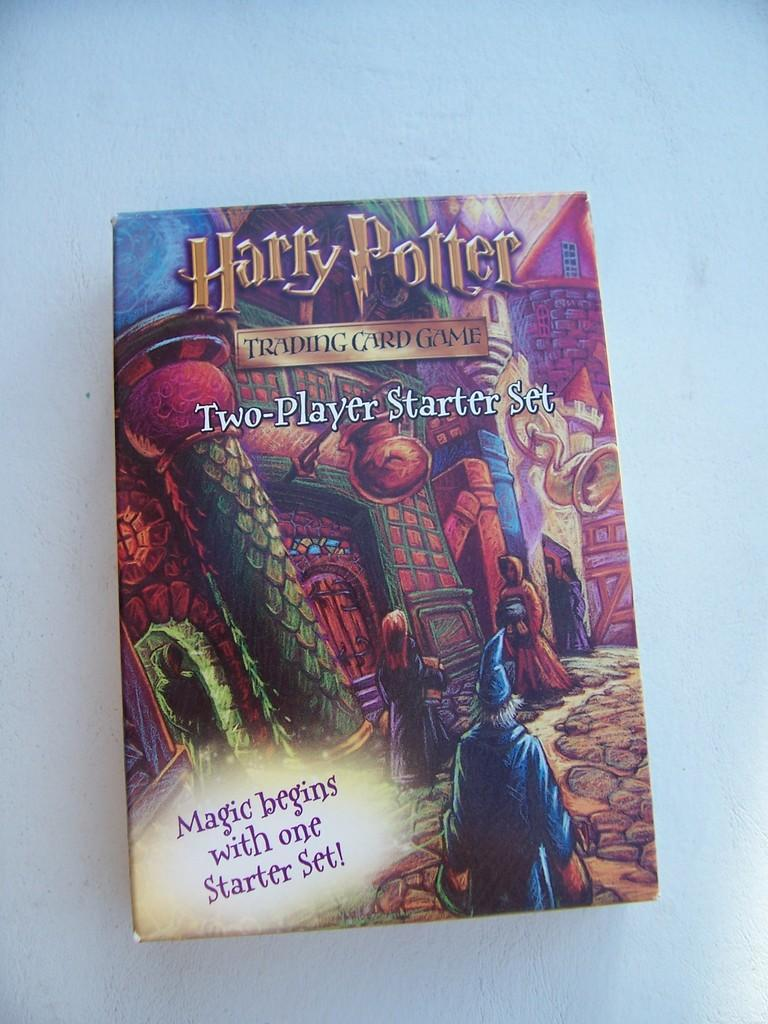<image>
Share a concise interpretation of the image provided. A two-player starter set of Harry Potter trading cards. 